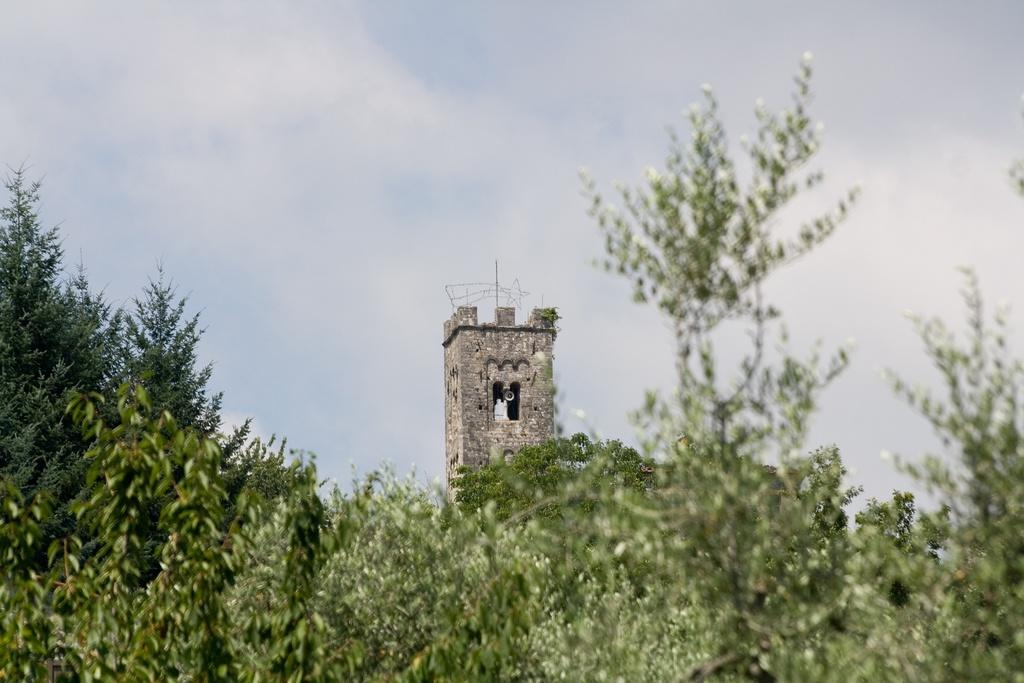What type of vegetation can be seen in the image? There are trees in the image. What type of structure is present in the image? There is a building tower in the image. What is visible in the background of the image? The sky is visible in the background of the image. Can you see a rabbit using a hammer to build the tower in the image? There is no rabbit or hammer present in the image. The image only features trees, a building tower, and the sky. 